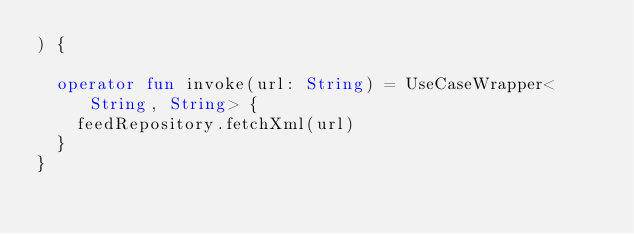<code> <loc_0><loc_0><loc_500><loc_500><_Kotlin_>) {

  operator fun invoke(url: String) = UseCaseWrapper<String, String> {
	feedRepository.fetchXml(url)
  }
}
</code> 